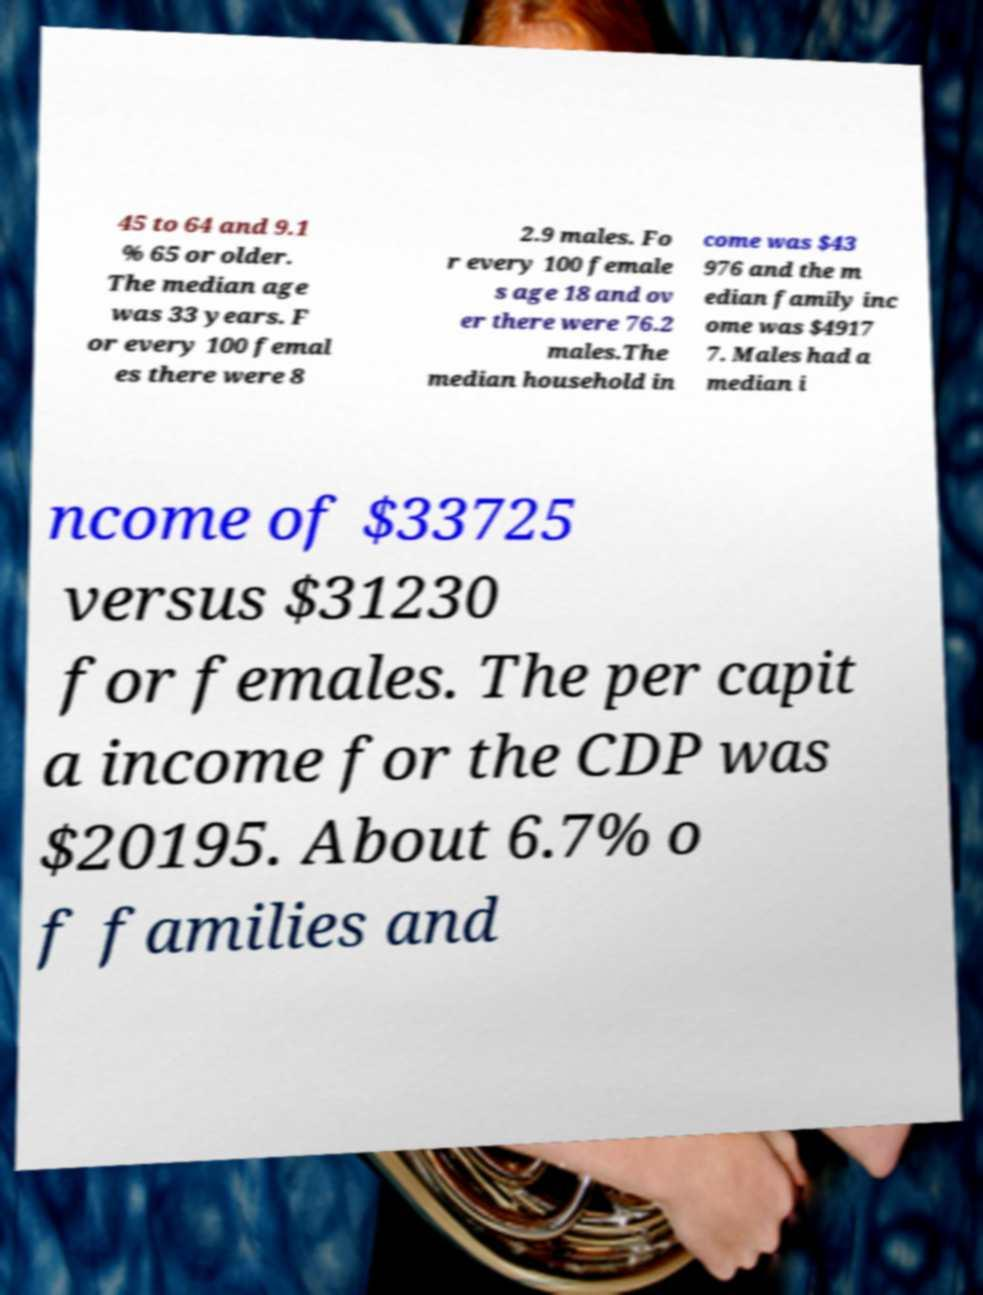Please read and relay the text visible in this image. What does it say? 45 to 64 and 9.1 % 65 or older. The median age was 33 years. F or every 100 femal es there were 8 2.9 males. Fo r every 100 female s age 18 and ov er there were 76.2 males.The median household in come was $43 976 and the m edian family inc ome was $4917 7. Males had a median i ncome of $33725 versus $31230 for females. The per capit a income for the CDP was $20195. About 6.7% o f families and 